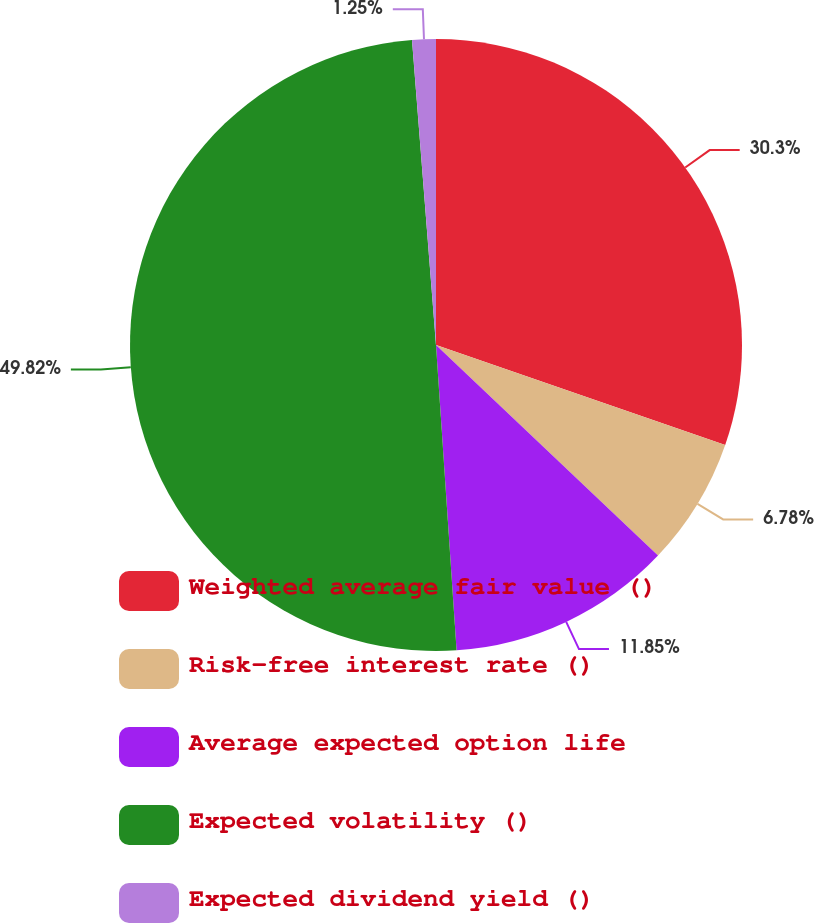Convert chart. <chart><loc_0><loc_0><loc_500><loc_500><pie_chart><fcel>Weighted average fair value ()<fcel>Risk-free interest rate ()<fcel>Average expected option life<fcel>Expected volatility ()<fcel>Expected dividend yield ()<nl><fcel>30.3%<fcel>6.78%<fcel>11.85%<fcel>49.82%<fcel>1.25%<nl></chart> 